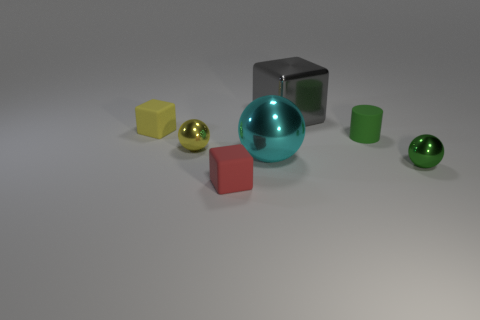What size is the gray metallic thing?
Provide a short and direct response. Large. What shape is the big gray object?
Make the answer very short. Cube. Are there any other things that are the same shape as the tiny yellow metallic object?
Your answer should be compact. Yes. Is the number of rubber things on the left side of the tiny yellow rubber thing less than the number of red cubes?
Offer a very short reply. Yes. There is a matte cube in front of the small yellow shiny ball; does it have the same color as the small rubber cylinder?
Offer a terse response. No. How many matte objects are either small red things or small green balls?
Offer a very short reply. 1. Is there anything else that has the same size as the red thing?
Give a very brief answer. Yes. There is a large ball that is the same material as the large block; what is its color?
Give a very brief answer. Cyan. How many balls are either yellow objects or green objects?
Your answer should be very brief. 2. What number of objects are large cyan balls or metal things that are on the right side of the yellow metallic object?
Offer a very short reply. 3. 